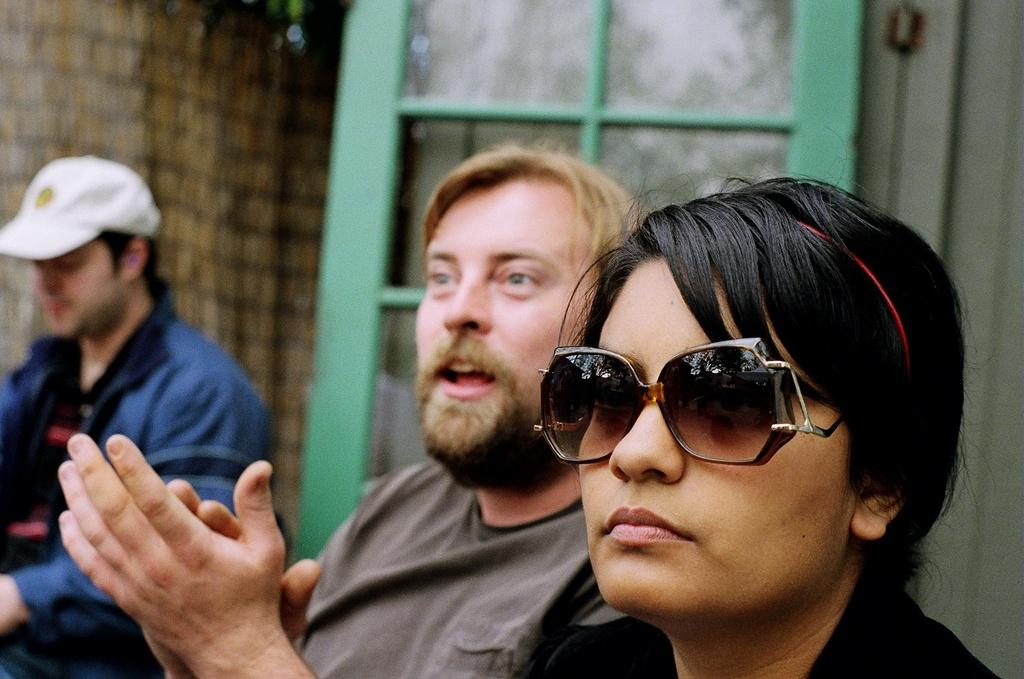How many people are in the foreground of the picture? There are two people, a man and a woman, in the foreground of the picture. What is the woman wearing that is unique to her appearance? The woman is wearing goggles. Can you describe the background of the image? The background of the image is blurred, and there is a person, a door, and a wall visible. What might be the purpose of the goggles the woman is wearing? The goggles might be for protection or to enhance her vision in a specific activity. What type of brick is being used to construct the crowd in the image? There is no crowd present in the image, nor is there any mention of bricks being used for construction. 